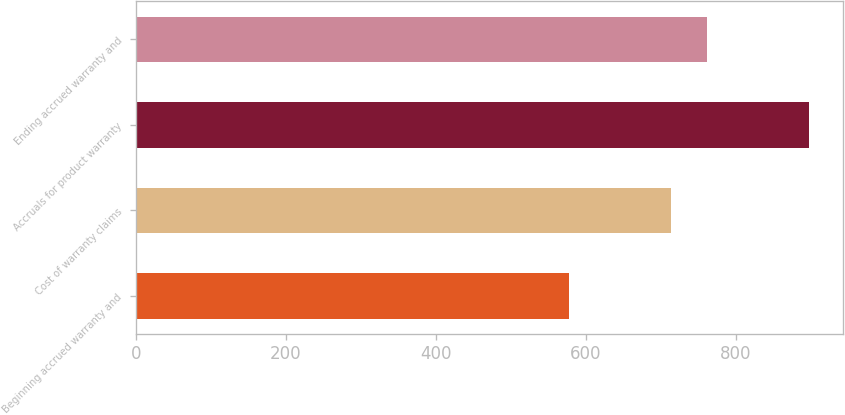<chart> <loc_0><loc_0><loc_500><loc_500><bar_chart><fcel>Beginning accrued warranty and<fcel>Cost of warranty claims<fcel>Accruals for product warranty<fcel>Ending accrued warranty and<nl><fcel>577<fcel>713<fcel>897<fcel>761<nl></chart> 